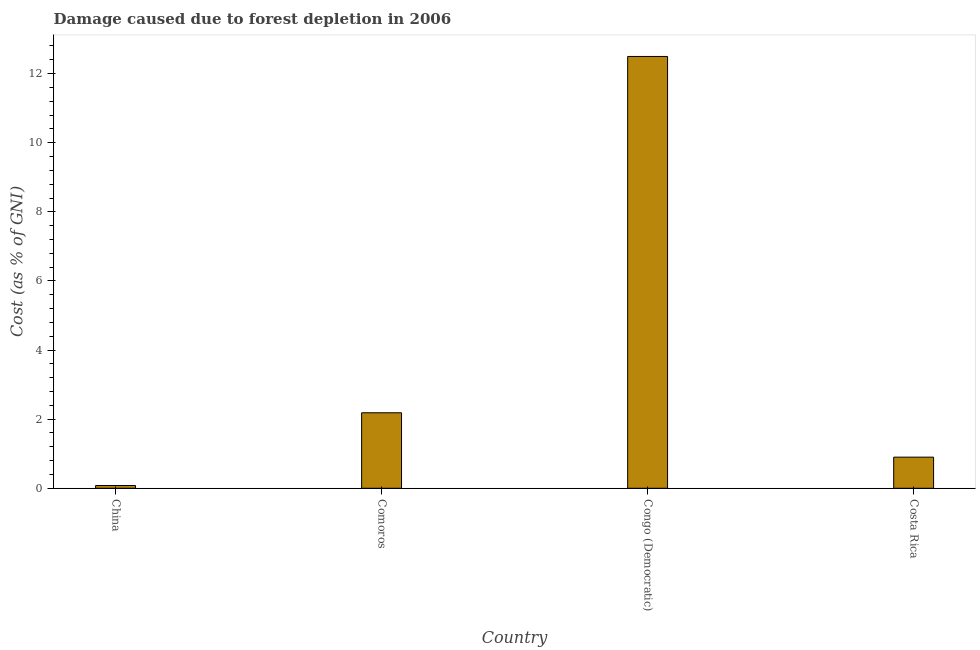What is the title of the graph?
Provide a short and direct response. Damage caused due to forest depletion in 2006. What is the label or title of the Y-axis?
Provide a short and direct response. Cost (as % of GNI). What is the damage caused due to forest depletion in Comoros?
Offer a terse response. 2.18. Across all countries, what is the maximum damage caused due to forest depletion?
Make the answer very short. 12.5. Across all countries, what is the minimum damage caused due to forest depletion?
Your answer should be compact. 0.08. In which country was the damage caused due to forest depletion maximum?
Make the answer very short. Congo (Democratic). What is the sum of the damage caused due to forest depletion?
Provide a succinct answer. 15.66. What is the difference between the damage caused due to forest depletion in Comoros and Congo (Democratic)?
Your answer should be very brief. -10.31. What is the average damage caused due to forest depletion per country?
Your answer should be compact. 3.92. What is the median damage caused due to forest depletion?
Your answer should be very brief. 1.54. In how many countries, is the damage caused due to forest depletion greater than 6.8 %?
Your answer should be compact. 1. What is the ratio of the damage caused due to forest depletion in China to that in Congo (Democratic)?
Your answer should be very brief. 0.01. Is the difference between the damage caused due to forest depletion in China and Congo (Democratic) greater than the difference between any two countries?
Your answer should be very brief. Yes. What is the difference between the highest and the second highest damage caused due to forest depletion?
Your answer should be very brief. 10.31. What is the difference between the highest and the lowest damage caused due to forest depletion?
Make the answer very short. 12.42. Are all the bars in the graph horizontal?
Offer a very short reply. No. How many countries are there in the graph?
Provide a succinct answer. 4. What is the difference between two consecutive major ticks on the Y-axis?
Offer a terse response. 2. Are the values on the major ticks of Y-axis written in scientific E-notation?
Make the answer very short. No. What is the Cost (as % of GNI) in China?
Your response must be concise. 0.08. What is the Cost (as % of GNI) of Comoros?
Keep it short and to the point. 2.18. What is the Cost (as % of GNI) of Congo (Democratic)?
Offer a very short reply. 12.5. What is the Cost (as % of GNI) in Costa Rica?
Keep it short and to the point. 0.9. What is the difference between the Cost (as % of GNI) in China and Comoros?
Give a very brief answer. -2.1. What is the difference between the Cost (as % of GNI) in China and Congo (Democratic)?
Your answer should be very brief. -12.42. What is the difference between the Cost (as % of GNI) in China and Costa Rica?
Make the answer very short. -0.82. What is the difference between the Cost (as % of GNI) in Comoros and Congo (Democratic)?
Provide a short and direct response. -10.31. What is the difference between the Cost (as % of GNI) in Comoros and Costa Rica?
Offer a terse response. 1.28. What is the difference between the Cost (as % of GNI) in Congo (Democratic) and Costa Rica?
Ensure brevity in your answer.  11.6. What is the ratio of the Cost (as % of GNI) in China to that in Comoros?
Your response must be concise. 0.04. What is the ratio of the Cost (as % of GNI) in China to that in Congo (Democratic)?
Provide a succinct answer. 0.01. What is the ratio of the Cost (as % of GNI) in China to that in Costa Rica?
Offer a terse response. 0.09. What is the ratio of the Cost (as % of GNI) in Comoros to that in Congo (Democratic)?
Give a very brief answer. 0.17. What is the ratio of the Cost (as % of GNI) in Comoros to that in Costa Rica?
Provide a succinct answer. 2.43. What is the ratio of the Cost (as % of GNI) in Congo (Democratic) to that in Costa Rica?
Give a very brief answer. 13.87. 